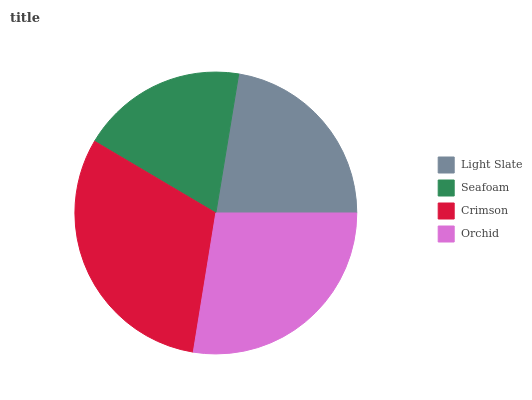Is Seafoam the minimum?
Answer yes or no. Yes. Is Crimson the maximum?
Answer yes or no. Yes. Is Crimson the minimum?
Answer yes or no. No. Is Seafoam the maximum?
Answer yes or no. No. Is Crimson greater than Seafoam?
Answer yes or no. Yes. Is Seafoam less than Crimson?
Answer yes or no. Yes. Is Seafoam greater than Crimson?
Answer yes or no. No. Is Crimson less than Seafoam?
Answer yes or no. No. Is Orchid the high median?
Answer yes or no. Yes. Is Light Slate the low median?
Answer yes or no. Yes. Is Crimson the high median?
Answer yes or no. No. Is Seafoam the low median?
Answer yes or no. No. 